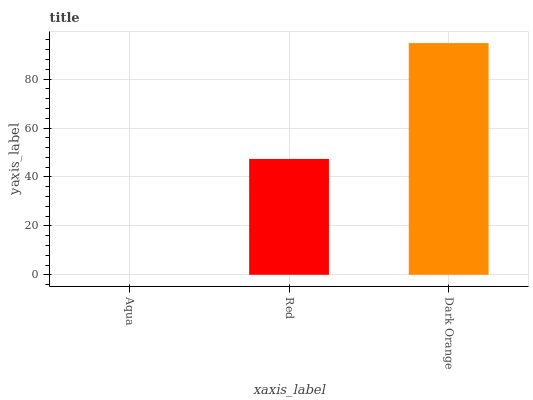Is Aqua the minimum?
Answer yes or no. Yes. Is Dark Orange the maximum?
Answer yes or no. Yes. Is Red the minimum?
Answer yes or no. No. Is Red the maximum?
Answer yes or no. No. Is Red greater than Aqua?
Answer yes or no. Yes. Is Aqua less than Red?
Answer yes or no. Yes. Is Aqua greater than Red?
Answer yes or no. No. Is Red less than Aqua?
Answer yes or no. No. Is Red the high median?
Answer yes or no. Yes. Is Red the low median?
Answer yes or no. Yes. Is Aqua the high median?
Answer yes or no. No. Is Aqua the low median?
Answer yes or no. No. 